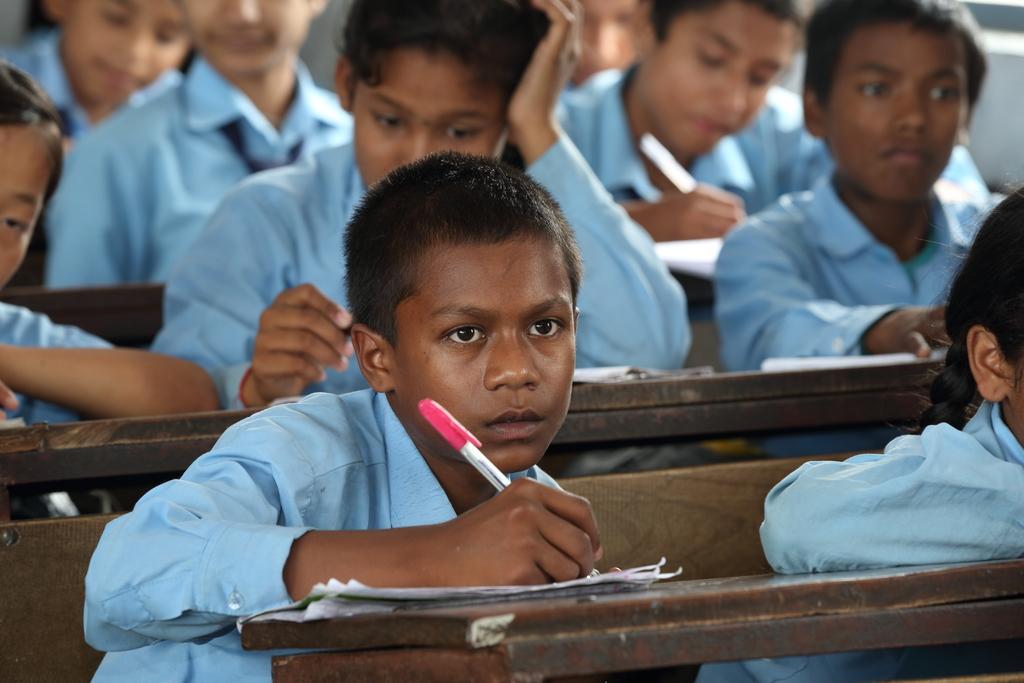In one or two sentences, can you explain what this image depicts? In this image we can see a group of students are sitting on the benches and writing something on the papers. 